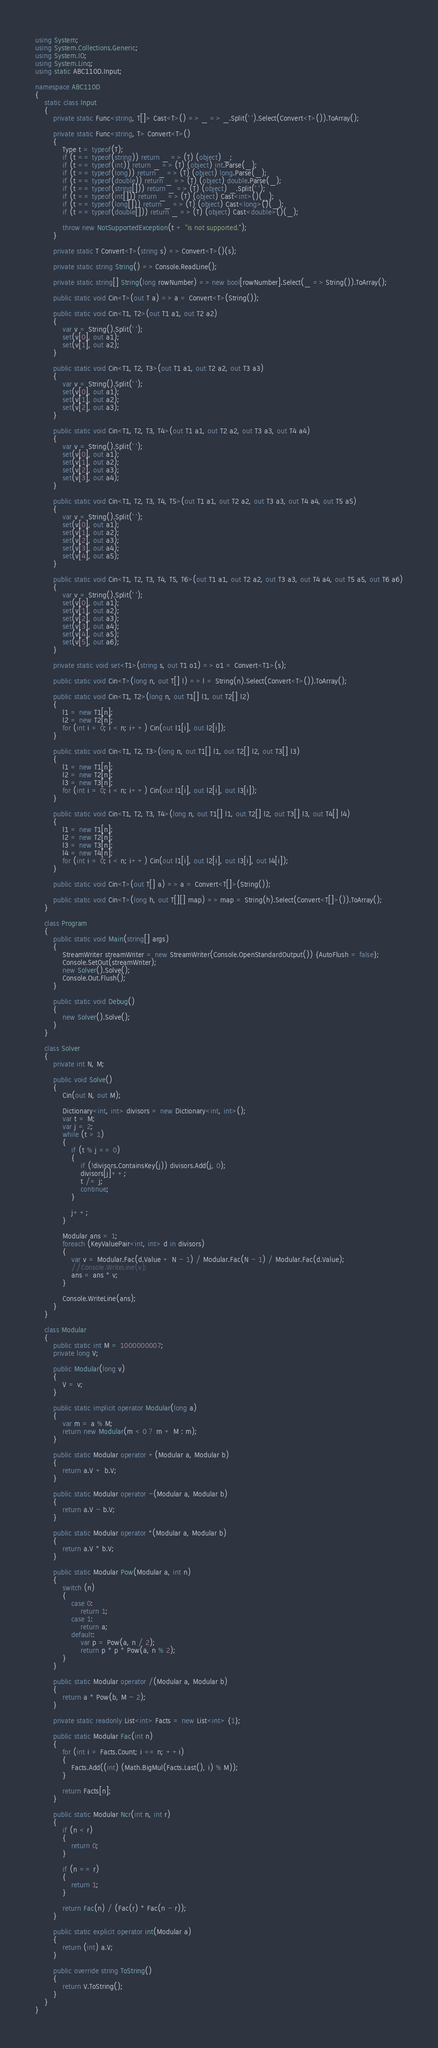Convert code to text. <code><loc_0><loc_0><loc_500><loc_500><_C#_>using System;
using System.Collections.Generic;
using System.IO;
using System.Linq;
using static ABC110D.Input;

namespace ABC110D
{
    static class Input
    {
        private static Func<string, T[]> Cast<T>() => _ => _.Split(' ').Select(Convert<T>()).ToArray();

        private static Func<string, T> Convert<T>()
        {
            Type t = typeof(T);
            if (t == typeof(string)) return _ => (T) (object) _;
            if (t == typeof(int)) return _ => (T) (object) int.Parse(_);
            if (t == typeof(long)) return _ => (T) (object) long.Parse(_);
            if (t == typeof(double)) return _ => (T) (object) double.Parse(_);
            if (t == typeof(string[])) return _ => (T) (object) _.Split(' ');
            if (t == typeof(int[])) return _ => (T) (object) Cast<int>()(_);
            if (t == typeof(long[])) return _ => (T) (object) Cast<long>()(_);
            if (t == typeof(double[])) return _ => (T) (object) Cast<double>()(_);

            throw new NotSupportedException(t + "is not supported.");
        }

        private static T Convert<T>(string s) => Convert<T>()(s);

        private static string String() => Console.ReadLine();

        private static string[] String(long rowNumber) => new bool[rowNumber].Select(_ => String()).ToArray();

        public static void Cin<T>(out T a) => a = Convert<T>(String());

        public static void Cin<T1, T2>(out T1 a1, out T2 a2)
        {
            var v = String().Split(' ');
            set(v[0], out a1);
            set(v[1], out a2);
        }

        public static void Cin<T1, T2, T3>(out T1 a1, out T2 a2, out T3 a3)
        {
            var v = String().Split(' ');
            set(v[0], out a1);
            set(v[1], out a2);
            set(v[2], out a3);
        }

        public static void Cin<T1, T2, T3, T4>(out T1 a1, out T2 a2, out T3 a3, out T4 a4)
        {
            var v = String().Split(' ');
            set(v[0], out a1);
            set(v[1], out a2);
            set(v[2], out a3);
            set(v[3], out a4);
        }

        public static void Cin<T1, T2, T3, T4, T5>(out T1 a1, out T2 a2, out T3 a3, out T4 a4, out T5 a5)
        {
            var v = String().Split(' ');
            set(v[0], out a1);
            set(v[1], out a2);
            set(v[2], out a3);
            set(v[3], out a4);
            set(v[4], out a5);
        }

        public static void Cin<T1, T2, T3, T4, T5, T6>(out T1 a1, out T2 a2, out T3 a3, out T4 a4, out T5 a5, out T6 a6)
        {
            var v = String().Split(' ');
            set(v[0], out a1);
            set(v[1], out a2);
            set(v[2], out a3);
            set(v[3], out a4);
            set(v[4], out a5);
            set(v[5], out a6);
        }

        private static void set<T1>(string s, out T1 o1) => o1 = Convert<T1>(s);

        public static void Cin<T>(long n, out T[] l) => l = String(n).Select(Convert<T>()).ToArray();

        public static void Cin<T1, T2>(long n, out T1[] l1, out T2[] l2)
        {
            l1 = new T1[n];
            l2 = new T2[n];
            for (int i = 0; i < n; i++) Cin(out l1[i], out l2[i]);
        }

        public static void Cin<T1, T2, T3>(long n, out T1[] l1, out T2[] l2, out T3[] l3)
        {
            l1 = new T1[n];
            l2 = new T2[n];
            l3 = new T3[n];
            for (int i = 0; i < n; i++) Cin(out l1[i], out l2[i], out l3[i]);
        }

        public static void Cin<T1, T2, T3, T4>(long n, out T1[] l1, out T2[] l2, out T3[] l3, out T4[] l4)
        {
            l1 = new T1[n];
            l2 = new T2[n];
            l3 = new T3[n];
            l4 = new T4[n];
            for (int i = 0; i < n; i++) Cin(out l1[i], out l2[i], out l3[i], out l4[i]);
        }

        public static void Cin<T>(out T[] a) => a = Convert<T[]>(String());

        public static void Cin<T>(long h, out T[][] map) => map = String(h).Select(Convert<T[]>()).ToArray();
    }

    class Program
    {
        public static void Main(string[] args)
        {
            StreamWriter streamWriter = new StreamWriter(Console.OpenStandardOutput()) {AutoFlush = false};
            Console.SetOut(streamWriter);
            new Solver().Solve();
            Console.Out.Flush();
        }

        public static void Debug()
        {
            new Solver().Solve();
        }
    }

    class Solver
    {
        private int N, M;

        public void Solve()
        {
            Cin(out N, out M);

            Dictionary<int, int> divisors = new Dictionary<int, int>();
            var t = M;
            var j = 2;
            while (t > 1)
            {
                if (t % j == 0)
                {
                    if (!divisors.ContainsKey(j)) divisors.Add(j, 0);
                    divisors[j]++;
                    t /= j;
                    continue;
                }

                j++;
            }

            Modular ans = 1;
            foreach (KeyValuePair<int, int> d in divisors)
            {
                var v = Modular.Fac(d.Value + N - 1) / Modular.Fac(N - 1) / Modular.Fac(d.Value);
                //Console.WriteLine(v);
                ans = ans * v;
            }

            Console.WriteLine(ans);
        }
    }

    class Modular
    {
        public static int M = 1000000007;
        private long V;

        public Modular(long v)
        {
            V = v;
        }

        public static implicit operator Modular(long a)
        {
            var m = a % M;
            return new Modular(m < 0 ? m + M : m);
        }

        public static Modular operator +(Modular a, Modular b)
        {
            return a.V + b.V;
        }

        public static Modular operator -(Modular a, Modular b)
        {
            return a.V - b.V;
        }

        public static Modular operator *(Modular a, Modular b)
        {
            return a.V * b.V;
        }

        public static Modular Pow(Modular a, int n)
        {
            switch (n)
            {
                case 0:
                    return 1;
                case 1:
                    return a;
                default:
                    var p = Pow(a, n / 2);
                    return p * p * Pow(a, n % 2);
            }
        }

        public static Modular operator /(Modular a, Modular b)
        {
            return a * Pow(b, M - 2);
        }

        private static readonly List<int> Facts = new List<int> {1};

        public static Modular Fac(int n)
        {
            for (int i = Facts.Count; i <= n; ++i)
            {
                Facts.Add((int) (Math.BigMul(Facts.Last(), i) % M));
            }

            return Facts[n];
        }

        public static Modular Ncr(int n, int r)
        {
            if (n < r)
            {
                return 0;
            }

            if (n == r)
            {
                return 1;
            }

            return Fac(n) / (Fac(r) * Fac(n - r));
        }

        public static explicit operator int(Modular a)
        {
            return (int) a.V;
        }

        public override string ToString()
        {
            return V.ToString();
        }
    }
}</code> 